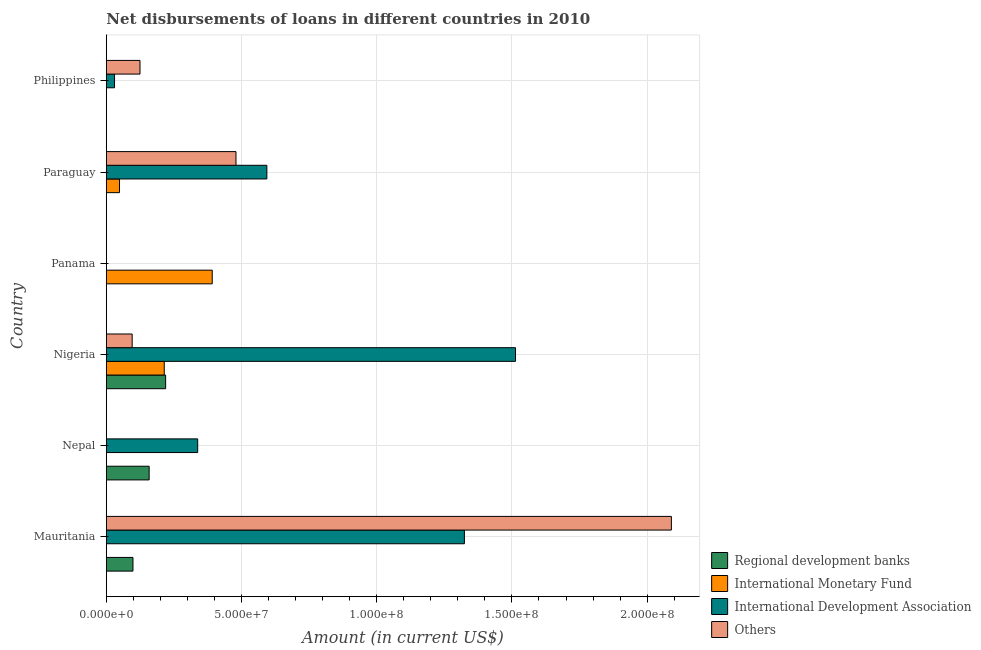How many different coloured bars are there?
Keep it short and to the point. 4. Are the number of bars per tick equal to the number of legend labels?
Give a very brief answer. No. How many bars are there on the 5th tick from the top?
Your response must be concise. 2. What is the label of the 3rd group of bars from the top?
Your answer should be compact. Panama. What is the amount of loan disimbursed by international development association in Nigeria?
Make the answer very short. 1.51e+08. Across all countries, what is the maximum amount of loan disimbursed by regional development banks?
Your answer should be very brief. 2.19e+07. In which country was the amount of loan disimbursed by other organisations maximum?
Give a very brief answer. Mauritania. What is the total amount of loan disimbursed by international development association in the graph?
Give a very brief answer. 3.80e+08. What is the difference between the amount of loan disimbursed by international monetary fund in Panama and that in Paraguay?
Provide a short and direct response. 3.43e+07. What is the difference between the amount of loan disimbursed by other organisations in Panama and the amount of loan disimbursed by international development association in Paraguay?
Your answer should be compact. -5.94e+07. What is the average amount of loan disimbursed by international development association per country?
Keep it short and to the point. 6.33e+07. What is the difference between the amount of loan disimbursed by other organisations and amount of loan disimbursed by international monetary fund in Nigeria?
Your response must be concise. -1.19e+07. In how many countries, is the amount of loan disimbursed by international monetary fund greater than 110000000 US$?
Keep it short and to the point. 0. What is the ratio of the amount of loan disimbursed by other organisations in Nigeria to that in Philippines?
Provide a short and direct response. 0.77. What is the difference between the highest and the second highest amount of loan disimbursed by international monetary fund?
Your answer should be very brief. 1.77e+07. What is the difference between the highest and the lowest amount of loan disimbursed by international development association?
Offer a very short reply. 1.51e+08. Is it the case that in every country, the sum of the amount of loan disimbursed by other organisations and amount of loan disimbursed by international development association is greater than the sum of amount of loan disimbursed by international monetary fund and amount of loan disimbursed by regional development banks?
Your response must be concise. No. How many bars are there?
Make the answer very short. 15. Does the graph contain grids?
Provide a succinct answer. Yes. How many legend labels are there?
Provide a short and direct response. 4. What is the title of the graph?
Offer a very short reply. Net disbursements of loans in different countries in 2010. What is the label or title of the X-axis?
Offer a terse response. Amount (in current US$). What is the Amount (in current US$) of Regional development banks in Mauritania?
Keep it short and to the point. 9.85e+06. What is the Amount (in current US$) in International Monetary Fund in Mauritania?
Offer a very short reply. 0. What is the Amount (in current US$) of International Development Association in Mauritania?
Provide a short and direct response. 1.32e+08. What is the Amount (in current US$) in Others in Mauritania?
Offer a very short reply. 2.09e+08. What is the Amount (in current US$) of Regional development banks in Nepal?
Offer a terse response. 1.58e+07. What is the Amount (in current US$) in International Monetary Fund in Nepal?
Your answer should be compact. 0. What is the Amount (in current US$) of International Development Association in Nepal?
Your answer should be compact. 3.38e+07. What is the Amount (in current US$) of Others in Nepal?
Give a very brief answer. 0. What is the Amount (in current US$) in Regional development banks in Nigeria?
Keep it short and to the point. 2.19e+07. What is the Amount (in current US$) of International Monetary Fund in Nigeria?
Offer a very short reply. 2.14e+07. What is the Amount (in current US$) of International Development Association in Nigeria?
Make the answer very short. 1.51e+08. What is the Amount (in current US$) in Others in Nigeria?
Offer a terse response. 9.56e+06. What is the Amount (in current US$) in Regional development banks in Panama?
Make the answer very short. 0. What is the Amount (in current US$) in International Monetary Fund in Panama?
Offer a very short reply. 3.92e+07. What is the Amount (in current US$) in International Development Association in Panama?
Keep it short and to the point. 0. What is the Amount (in current US$) of Regional development banks in Paraguay?
Ensure brevity in your answer.  0. What is the Amount (in current US$) of International Monetary Fund in Paraguay?
Provide a succinct answer. 4.88e+06. What is the Amount (in current US$) in International Development Association in Paraguay?
Offer a very short reply. 5.94e+07. What is the Amount (in current US$) in Others in Paraguay?
Keep it short and to the point. 4.79e+07. What is the Amount (in current US$) in Regional development banks in Philippines?
Offer a terse response. 0. What is the Amount (in current US$) in International Monetary Fund in Philippines?
Your response must be concise. 0. What is the Amount (in current US$) of International Development Association in Philippines?
Offer a very short reply. 3.03e+06. What is the Amount (in current US$) in Others in Philippines?
Ensure brevity in your answer.  1.24e+07. Across all countries, what is the maximum Amount (in current US$) in Regional development banks?
Your response must be concise. 2.19e+07. Across all countries, what is the maximum Amount (in current US$) of International Monetary Fund?
Ensure brevity in your answer.  3.92e+07. Across all countries, what is the maximum Amount (in current US$) in International Development Association?
Give a very brief answer. 1.51e+08. Across all countries, what is the maximum Amount (in current US$) of Others?
Keep it short and to the point. 2.09e+08. Across all countries, what is the minimum Amount (in current US$) in Regional development banks?
Provide a short and direct response. 0. Across all countries, what is the minimum Amount (in current US$) of International Monetary Fund?
Make the answer very short. 0. Across all countries, what is the minimum Amount (in current US$) in International Development Association?
Ensure brevity in your answer.  0. What is the total Amount (in current US$) in Regional development banks in the graph?
Give a very brief answer. 4.76e+07. What is the total Amount (in current US$) in International Monetary Fund in the graph?
Provide a short and direct response. 6.55e+07. What is the total Amount (in current US$) in International Development Association in the graph?
Your answer should be compact. 3.80e+08. What is the total Amount (in current US$) of Others in the graph?
Give a very brief answer. 2.79e+08. What is the difference between the Amount (in current US$) in Regional development banks in Mauritania and that in Nepal?
Offer a very short reply. -5.99e+06. What is the difference between the Amount (in current US$) in International Development Association in Mauritania and that in Nepal?
Provide a short and direct response. 9.86e+07. What is the difference between the Amount (in current US$) of Regional development banks in Mauritania and that in Nigeria?
Your answer should be compact. -1.21e+07. What is the difference between the Amount (in current US$) in International Development Association in Mauritania and that in Nigeria?
Your response must be concise. -1.89e+07. What is the difference between the Amount (in current US$) of Others in Mauritania and that in Nigeria?
Ensure brevity in your answer.  1.99e+08. What is the difference between the Amount (in current US$) in International Development Association in Mauritania and that in Paraguay?
Your response must be concise. 7.31e+07. What is the difference between the Amount (in current US$) in Others in Mauritania and that in Paraguay?
Give a very brief answer. 1.61e+08. What is the difference between the Amount (in current US$) of International Development Association in Mauritania and that in Philippines?
Your answer should be very brief. 1.29e+08. What is the difference between the Amount (in current US$) in Others in Mauritania and that in Philippines?
Offer a very short reply. 1.97e+08. What is the difference between the Amount (in current US$) of Regional development banks in Nepal and that in Nigeria?
Make the answer very short. -6.10e+06. What is the difference between the Amount (in current US$) of International Development Association in Nepal and that in Nigeria?
Offer a terse response. -1.18e+08. What is the difference between the Amount (in current US$) of International Development Association in Nepal and that in Paraguay?
Provide a short and direct response. -2.56e+07. What is the difference between the Amount (in current US$) in International Development Association in Nepal and that in Philippines?
Your answer should be compact. 3.08e+07. What is the difference between the Amount (in current US$) of International Monetary Fund in Nigeria and that in Panama?
Give a very brief answer. -1.77e+07. What is the difference between the Amount (in current US$) of International Monetary Fund in Nigeria and that in Paraguay?
Offer a very short reply. 1.65e+07. What is the difference between the Amount (in current US$) of International Development Association in Nigeria and that in Paraguay?
Provide a succinct answer. 9.20e+07. What is the difference between the Amount (in current US$) of Others in Nigeria and that in Paraguay?
Your answer should be compact. -3.84e+07. What is the difference between the Amount (in current US$) in International Development Association in Nigeria and that in Philippines?
Provide a succinct answer. 1.48e+08. What is the difference between the Amount (in current US$) of Others in Nigeria and that in Philippines?
Your answer should be compact. -2.90e+06. What is the difference between the Amount (in current US$) of International Monetary Fund in Panama and that in Paraguay?
Provide a succinct answer. 3.43e+07. What is the difference between the Amount (in current US$) of International Development Association in Paraguay and that in Philippines?
Give a very brief answer. 5.63e+07. What is the difference between the Amount (in current US$) in Others in Paraguay and that in Philippines?
Offer a very short reply. 3.55e+07. What is the difference between the Amount (in current US$) in Regional development banks in Mauritania and the Amount (in current US$) in International Development Association in Nepal?
Your response must be concise. -2.39e+07. What is the difference between the Amount (in current US$) in Regional development banks in Mauritania and the Amount (in current US$) in International Monetary Fund in Nigeria?
Offer a terse response. -1.16e+07. What is the difference between the Amount (in current US$) in Regional development banks in Mauritania and the Amount (in current US$) in International Development Association in Nigeria?
Make the answer very short. -1.41e+08. What is the difference between the Amount (in current US$) of Regional development banks in Mauritania and the Amount (in current US$) of Others in Nigeria?
Offer a very short reply. 2.95e+05. What is the difference between the Amount (in current US$) in International Development Association in Mauritania and the Amount (in current US$) in Others in Nigeria?
Offer a very short reply. 1.23e+08. What is the difference between the Amount (in current US$) of Regional development banks in Mauritania and the Amount (in current US$) of International Monetary Fund in Panama?
Offer a very short reply. -2.93e+07. What is the difference between the Amount (in current US$) of Regional development banks in Mauritania and the Amount (in current US$) of International Monetary Fund in Paraguay?
Give a very brief answer. 4.97e+06. What is the difference between the Amount (in current US$) in Regional development banks in Mauritania and the Amount (in current US$) in International Development Association in Paraguay?
Provide a succinct answer. -4.95e+07. What is the difference between the Amount (in current US$) of Regional development banks in Mauritania and the Amount (in current US$) of Others in Paraguay?
Ensure brevity in your answer.  -3.81e+07. What is the difference between the Amount (in current US$) in International Development Association in Mauritania and the Amount (in current US$) in Others in Paraguay?
Keep it short and to the point. 8.45e+07. What is the difference between the Amount (in current US$) of Regional development banks in Mauritania and the Amount (in current US$) of International Development Association in Philippines?
Your answer should be very brief. 6.82e+06. What is the difference between the Amount (in current US$) in Regional development banks in Mauritania and the Amount (in current US$) in Others in Philippines?
Give a very brief answer. -2.60e+06. What is the difference between the Amount (in current US$) in International Development Association in Mauritania and the Amount (in current US$) in Others in Philippines?
Your response must be concise. 1.20e+08. What is the difference between the Amount (in current US$) of Regional development banks in Nepal and the Amount (in current US$) of International Monetary Fund in Nigeria?
Your response must be concise. -5.58e+06. What is the difference between the Amount (in current US$) in Regional development banks in Nepal and the Amount (in current US$) in International Development Association in Nigeria?
Your response must be concise. -1.35e+08. What is the difference between the Amount (in current US$) of Regional development banks in Nepal and the Amount (in current US$) of Others in Nigeria?
Offer a very short reply. 6.28e+06. What is the difference between the Amount (in current US$) in International Development Association in Nepal and the Amount (in current US$) in Others in Nigeria?
Your answer should be very brief. 2.42e+07. What is the difference between the Amount (in current US$) of Regional development banks in Nepal and the Amount (in current US$) of International Monetary Fund in Panama?
Provide a succinct answer. -2.33e+07. What is the difference between the Amount (in current US$) of Regional development banks in Nepal and the Amount (in current US$) of International Monetary Fund in Paraguay?
Offer a terse response. 1.10e+07. What is the difference between the Amount (in current US$) of Regional development banks in Nepal and the Amount (in current US$) of International Development Association in Paraguay?
Make the answer very short. -4.35e+07. What is the difference between the Amount (in current US$) of Regional development banks in Nepal and the Amount (in current US$) of Others in Paraguay?
Your response must be concise. -3.21e+07. What is the difference between the Amount (in current US$) in International Development Association in Nepal and the Amount (in current US$) in Others in Paraguay?
Give a very brief answer. -1.42e+07. What is the difference between the Amount (in current US$) of Regional development banks in Nepal and the Amount (in current US$) of International Development Association in Philippines?
Ensure brevity in your answer.  1.28e+07. What is the difference between the Amount (in current US$) of Regional development banks in Nepal and the Amount (in current US$) of Others in Philippines?
Provide a short and direct response. 3.39e+06. What is the difference between the Amount (in current US$) of International Development Association in Nepal and the Amount (in current US$) of Others in Philippines?
Ensure brevity in your answer.  2.13e+07. What is the difference between the Amount (in current US$) of Regional development banks in Nigeria and the Amount (in current US$) of International Monetary Fund in Panama?
Offer a very short reply. -1.72e+07. What is the difference between the Amount (in current US$) in Regional development banks in Nigeria and the Amount (in current US$) in International Monetary Fund in Paraguay?
Your response must be concise. 1.71e+07. What is the difference between the Amount (in current US$) in Regional development banks in Nigeria and the Amount (in current US$) in International Development Association in Paraguay?
Provide a short and direct response. -3.74e+07. What is the difference between the Amount (in current US$) in Regional development banks in Nigeria and the Amount (in current US$) in Others in Paraguay?
Provide a succinct answer. -2.60e+07. What is the difference between the Amount (in current US$) in International Monetary Fund in Nigeria and the Amount (in current US$) in International Development Association in Paraguay?
Provide a short and direct response. -3.79e+07. What is the difference between the Amount (in current US$) of International Monetary Fund in Nigeria and the Amount (in current US$) of Others in Paraguay?
Provide a short and direct response. -2.65e+07. What is the difference between the Amount (in current US$) in International Development Association in Nigeria and the Amount (in current US$) in Others in Paraguay?
Offer a terse response. 1.03e+08. What is the difference between the Amount (in current US$) in Regional development banks in Nigeria and the Amount (in current US$) in International Development Association in Philippines?
Your answer should be very brief. 1.89e+07. What is the difference between the Amount (in current US$) of Regional development banks in Nigeria and the Amount (in current US$) of Others in Philippines?
Offer a very short reply. 9.48e+06. What is the difference between the Amount (in current US$) in International Monetary Fund in Nigeria and the Amount (in current US$) in International Development Association in Philippines?
Ensure brevity in your answer.  1.84e+07. What is the difference between the Amount (in current US$) in International Monetary Fund in Nigeria and the Amount (in current US$) in Others in Philippines?
Provide a succinct answer. 8.97e+06. What is the difference between the Amount (in current US$) of International Development Association in Nigeria and the Amount (in current US$) of Others in Philippines?
Keep it short and to the point. 1.39e+08. What is the difference between the Amount (in current US$) of International Monetary Fund in Panama and the Amount (in current US$) of International Development Association in Paraguay?
Give a very brief answer. -2.02e+07. What is the difference between the Amount (in current US$) in International Monetary Fund in Panama and the Amount (in current US$) in Others in Paraguay?
Offer a very short reply. -8.78e+06. What is the difference between the Amount (in current US$) of International Monetary Fund in Panama and the Amount (in current US$) of International Development Association in Philippines?
Ensure brevity in your answer.  3.61e+07. What is the difference between the Amount (in current US$) of International Monetary Fund in Panama and the Amount (in current US$) of Others in Philippines?
Your answer should be very brief. 2.67e+07. What is the difference between the Amount (in current US$) of International Monetary Fund in Paraguay and the Amount (in current US$) of International Development Association in Philippines?
Give a very brief answer. 1.84e+06. What is the difference between the Amount (in current US$) in International Monetary Fund in Paraguay and the Amount (in current US$) in Others in Philippines?
Your answer should be compact. -7.57e+06. What is the difference between the Amount (in current US$) of International Development Association in Paraguay and the Amount (in current US$) of Others in Philippines?
Offer a very short reply. 4.69e+07. What is the average Amount (in current US$) of Regional development banks per country?
Provide a succinct answer. 7.94e+06. What is the average Amount (in current US$) in International Monetary Fund per country?
Your response must be concise. 1.09e+07. What is the average Amount (in current US$) of International Development Association per country?
Your answer should be compact. 6.33e+07. What is the average Amount (in current US$) of Others per country?
Your response must be concise. 4.65e+07. What is the difference between the Amount (in current US$) of Regional development banks and Amount (in current US$) of International Development Association in Mauritania?
Ensure brevity in your answer.  -1.23e+08. What is the difference between the Amount (in current US$) in Regional development banks and Amount (in current US$) in Others in Mauritania?
Offer a very short reply. -1.99e+08. What is the difference between the Amount (in current US$) of International Development Association and Amount (in current US$) of Others in Mauritania?
Offer a terse response. -7.65e+07. What is the difference between the Amount (in current US$) of Regional development banks and Amount (in current US$) of International Development Association in Nepal?
Offer a terse response. -1.80e+07. What is the difference between the Amount (in current US$) in Regional development banks and Amount (in current US$) in International Monetary Fund in Nigeria?
Your answer should be very brief. 5.14e+05. What is the difference between the Amount (in current US$) in Regional development banks and Amount (in current US$) in International Development Association in Nigeria?
Your response must be concise. -1.29e+08. What is the difference between the Amount (in current US$) of Regional development banks and Amount (in current US$) of Others in Nigeria?
Ensure brevity in your answer.  1.24e+07. What is the difference between the Amount (in current US$) of International Monetary Fund and Amount (in current US$) of International Development Association in Nigeria?
Keep it short and to the point. -1.30e+08. What is the difference between the Amount (in current US$) in International Monetary Fund and Amount (in current US$) in Others in Nigeria?
Ensure brevity in your answer.  1.19e+07. What is the difference between the Amount (in current US$) of International Development Association and Amount (in current US$) of Others in Nigeria?
Provide a succinct answer. 1.42e+08. What is the difference between the Amount (in current US$) in International Monetary Fund and Amount (in current US$) in International Development Association in Paraguay?
Provide a succinct answer. -5.45e+07. What is the difference between the Amount (in current US$) of International Monetary Fund and Amount (in current US$) of Others in Paraguay?
Your answer should be compact. -4.31e+07. What is the difference between the Amount (in current US$) of International Development Association and Amount (in current US$) of Others in Paraguay?
Make the answer very short. 1.14e+07. What is the difference between the Amount (in current US$) of International Development Association and Amount (in current US$) of Others in Philippines?
Make the answer very short. -9.42e+06. What is the ratio of the Amount (in current US$) in Regional development banks in Mauritania to that in Nepal?
Provide a succinct answer. 0.62. What is the ratio of the Amount (in current US$) of International Development Association in Mauritania to that in Nepal?
Provide a succinct answer. 3.92. What is the ratio of the Amount (in current US$) of Regional development banks in Mauritania to that in Nigeria?
Your response must be concise. 0.45. What is the ratio of the Amount (in current US$) of International Development Association in Mauritania to that in Nigeria?
Give a very brief answer. 0.88. What is the ratio of the Amount (in current US$) of Others in Mauritania to that in Nigeria?
Make the answer very short. 21.87. What is the ratio of the Amount (in current US$) of International Development Association in Mauritania to that in Paraguay?
Provide a short and direct response. 2.23. What is the ratio of the Amount (in current US$) in Others in Mauritania to that in Paraguay?
Offer a very short reply. 4.36. What is the ratio of the Amount (in current US$) of International Development Association in Mauritania to that in Philippines?
Provide a short and direct response. 43.68. What is the ratio of the Amount (in current US$) of Others in Mauritania to that in Philippines?
Keep it short and to the point. 16.78. What is the ratio of the Amount (in current US$) in Regional development banks in Nepal to that in Nigeria?
Provide a short and direct response. 0.72. What is the ratio of the Amount (in current US$) of International Development Association in Nepal to that in Nigeria?
Offer a very short reply. 0.22. What is the ratio of the Amount (in current US$) of International Development Association in Nepal to that in Paraguay?
Provide a succinct answer. 0.57. What is the ratio of the Amount (in current US$) of International Development Association in Nepal to that in Philippines?
Offer a terse response. 11.14. What is the ratio of the Amount (in current US$) of International Monetary Fund in Nigeria to that in Panama?
Your response must be concise. 0.55. What is the ratio of the Amount (in current US$) of International Monetary Fund in Nigeria to that in Paraguay?
Your answer should be compact. 4.39. What is the ratio of the Amount (in current US$) in International Development Association in Nigeria to that in Paraguay?
Give a very brief answer. 2.55. What is the ratio of the Amount (in current US$) in Others in Nigeria to that in Paraguay?
Keep it short and to the point. 0.2. What is the ratio of the Amount (in current US$) in International Development Association in Nigeria to that in Philippines?
Give a very brief answer. 49.91. What is the ratio of the Amount (in current US$) of Others in Nigeria to that in Philippines?
Make the answer very short. 0.77. What is the ratio of the Amount (in current US$) of International Monetary Fund in Panama to that in Paraguay?
Your answer should be compact. 8.03. What is the ratio of the Amount (in current US$) of International Development Association in Paraguay to that in Philippines?
Your answer should be compact. 19.58. What is the ratio of the Amount (in current US$) in Others in Paraguay to that in Philippines?
Offer a very short reply. 3.85. What is the difference between the highest and the second highest Amount (in current US$) in Regional development banks?
Provide a succinct answer. 6.10e+06. What is the difference between the highest and the second highest Amount (in current US$) in International Monetary Fund?
Make the answer very short. 1.77e+07. What is the difference between the highest and the second highest Amount (in current US$) in International Development Association?
Your response must be concise. 1.89e+07. What is the difference between the highest and the second highest Amount (in current US$) in Others?
Make the answer very short. 1.61e+08. What is the difference between the highest and the lowest Amount (in current US$) in Regional development banks?
Offer a terse response. 2.19e+07. What is the difference between the highest and the lowest Amount (in current US$) in International Monetary Fund?
Your response must be concise. 3.92e+07. What is the difference between the highest and the lowest Amount (in current US$) of International Development Association?
Offer a very short reply. 1.51e+08. What is the difference between the highest and the lowest Amount (in current US$) of Others?
Provide a short and direct response. 2.09e+08. 